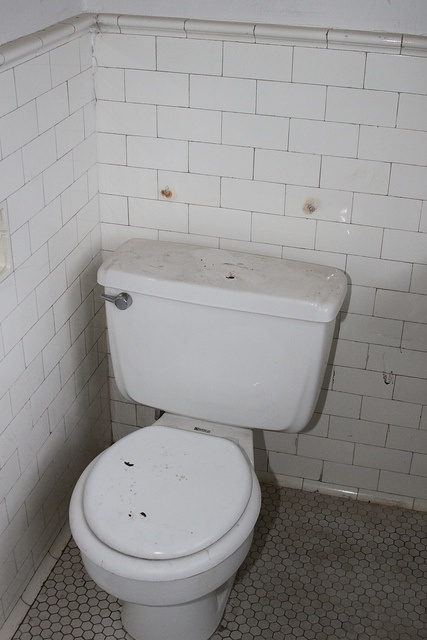Describe the objects in this image and their specific colors. I can see a toilet in darkgray, gray, and black tones in this image. 